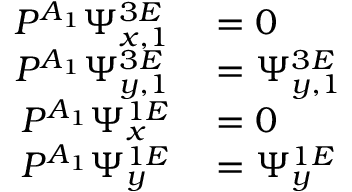<formula> <loc_0><loc_0><loc_500><loc_500>\begin{array} { r } { \begin{array} { r l } { P ^ { A _ { 1 } } \Psi _ { x , 1 } ^ { 3 E } } & = 0 } \\ { P ^ { A _ { 1 } } \Psi _ { y , 1 } ^ { 3 E } } & = \Psi _ { y , 1 } ^ { 3 E } } \\ { P ^ { A _ { 1 } } \Psi _ { x } ^ { 1 E } } & = 0 } \\ { P ^ { A _ { 1 } } \Psi _ { y } ^ { 1 E } } & = \Psi _ { y } ^ { 1 E } } \end{array} } \end{array}</formula> 